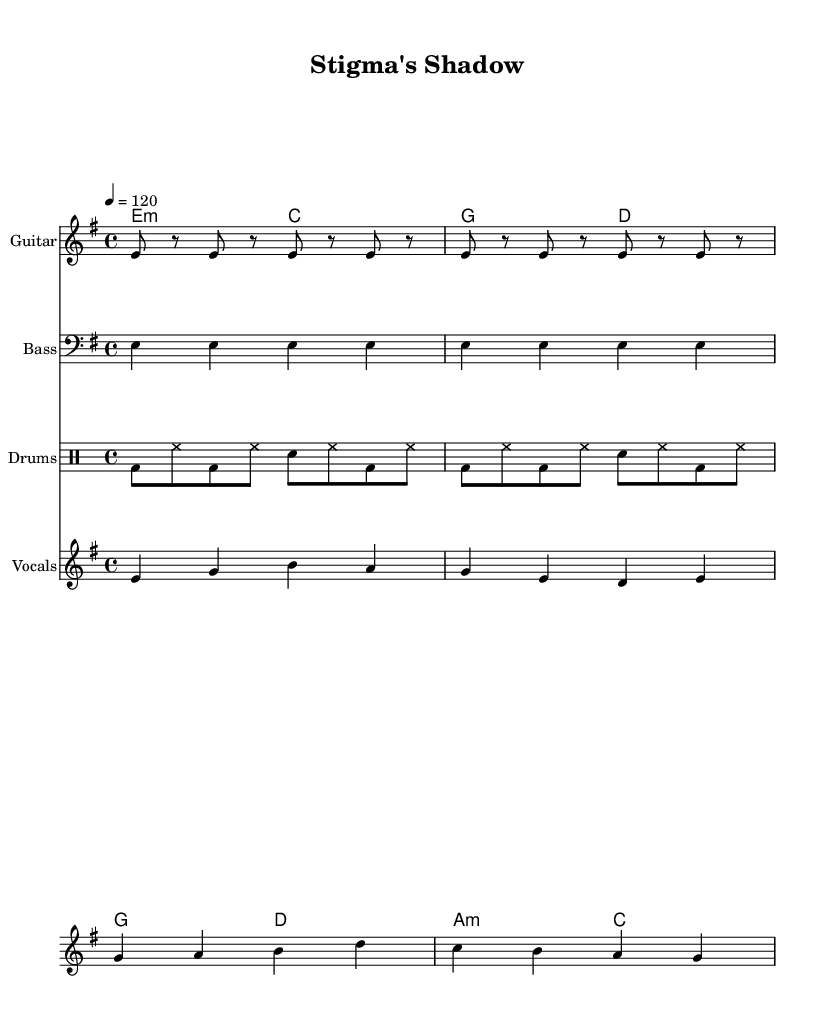What is the key signature of this music? The key signature is E minor, which has one sharp (F#). This can be identified at the beginning of the sheet music where the key signature is indicated.
Answer: E minor What is the time signature of the song? The time signature is 4/4, which is indicated at the beginning of the score. This means there are four beats in each measure and a quarter note receives one beat.
Answer: 4/4 What is the tempo of the piece? The tempo is indicated as quarter note equals 120 beats per minute. This is denoted with the term "tempo" in the score, alongside the numerical value.
Answer: 120 How many measures are in the verse? The verse contains four measures, which can be seen in the notation for the melody and lyrics provided; each line corresponds to one measure.
Answer: Four measures What are the first two chords of the verse? The first two chords of the verse are E minor and C major. These can be found in the chord section of the sheet music labeled as verse chords.
Answer: E minor, C major Which instrument is responsible for the guitar riff? The guitar staff is responsible for the guitar riff, as indicated in the instrument name at the top of the staff section in the sheet music.
Answer: Guitar What phrase encapsulates the main message of the chorus? The main message of the chorus is "Mental health, nothing to doubt." This is derived from analyzing the lyrics under the melody labeled as the chorus in the sheet music.
Answer: Mental health, nothing to doubt 